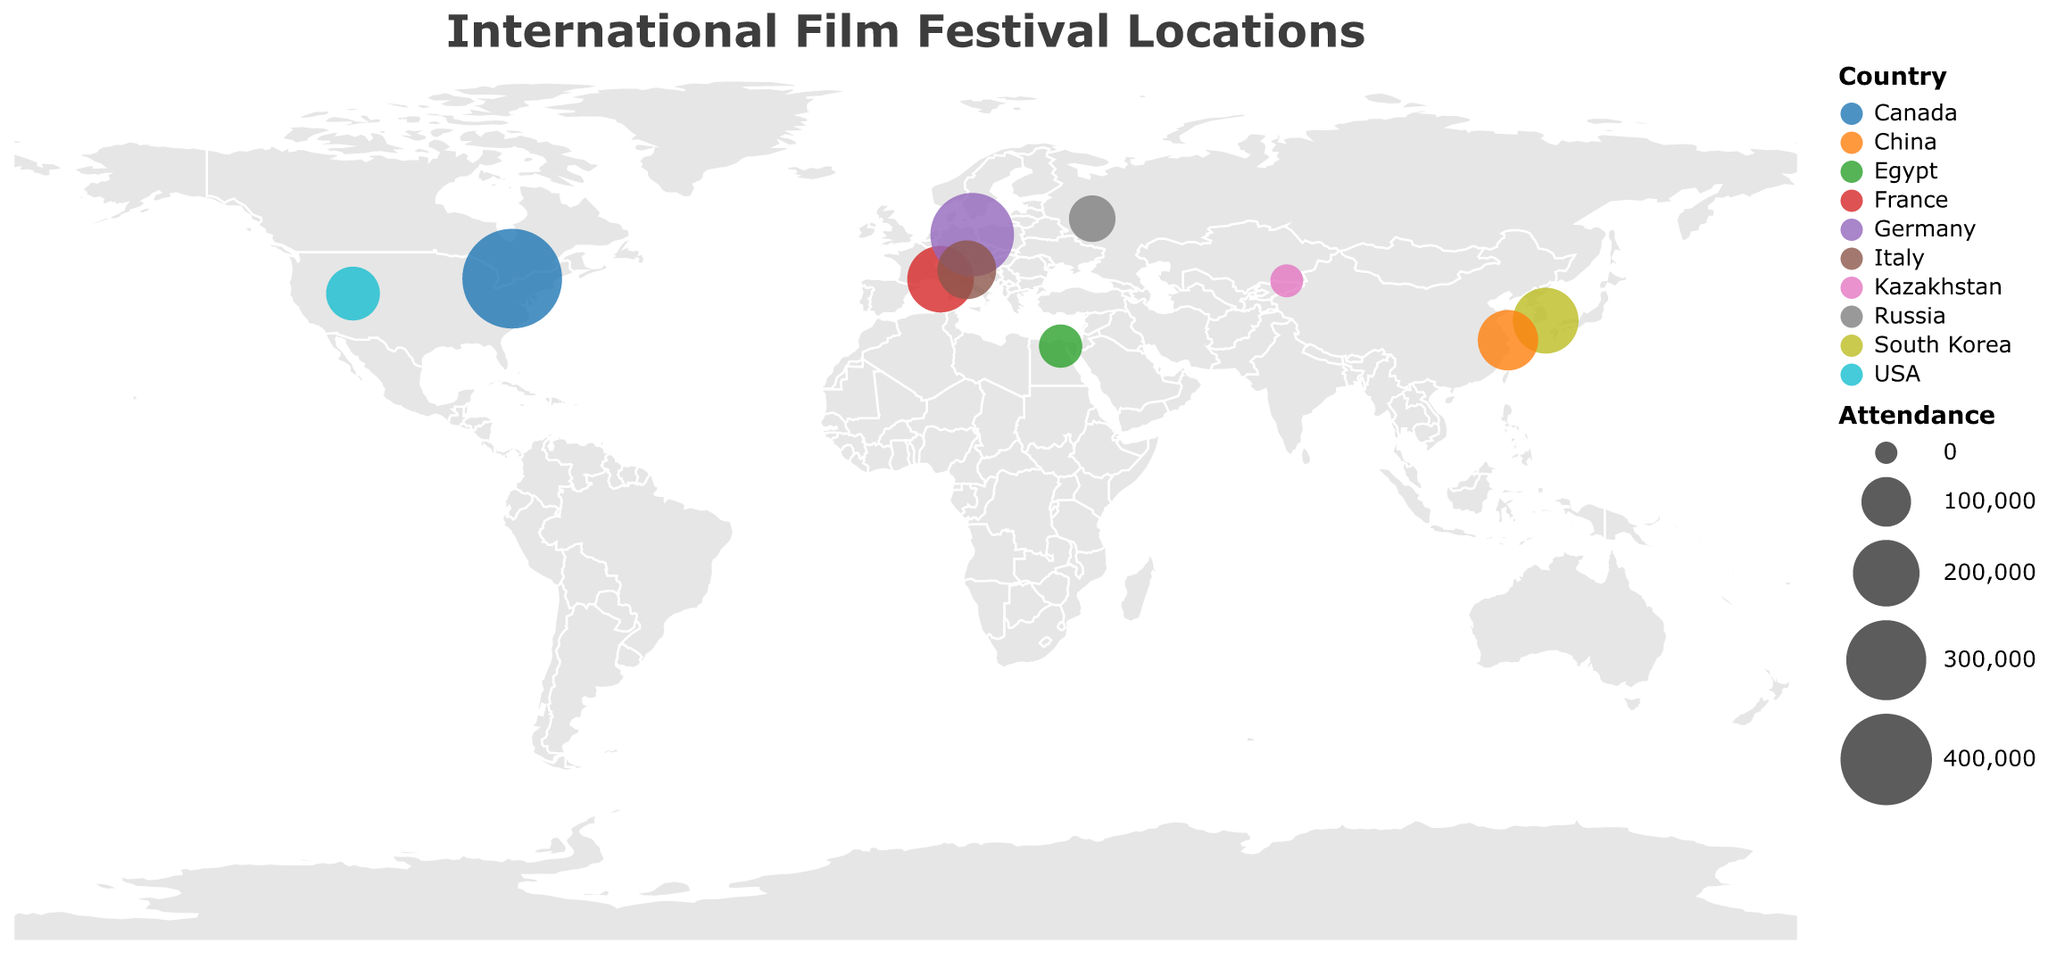What is the title of the figure? The title is displayed at the top of the figure in a larger font size. From the data, it is described as "International Film Festival Locations."
Answer: International Film Festival Locations How many film festivals are shown on the plot? Each circle on the map represents a film festival. By counting the circles or using the data provided, there are 10 film festivals depicted.
Answer: 10 Which film festival has the highest attendance? Look at the size of the circles on the plot. The largest circle corresponds to the Toronto International Film Festival. According to the data, its attendance is 480,000, the highest.
Answer: Toronto International Film Festival What is the attendance of the film festival in Almaty, Kazakhstan? Hover over or look at the circle located at the coordinates for Almaty, Kazakhstan. From the data, the attendance is 30,000.
Answer: 30,000 Which film festival occurs at the highest latitude? The Berlin International Film Festival occurs in Berlin, Germany, which has the highest latitude of 52.5200 among the listed festivals.
Answer: Berlin International Film Festival How does the attendance of the Busan International Film Festival compare to that of the Moscow International Film Festival? Look at the circle sizes and data. Busan International Film Festival has 195,000 attendees, while Moscow International Film Festival has 85,000 attendees. Thus, Busan's attendance is higher.
Answer: Busan International Film Festival has a higher attendance Which countries have more than one film festival depicted? By analyzing the countries listed in the data and their corresponding circles on the map, none of the countries have more than one film festival depicted.
Answer: None What is the total attendance of all film festivals combined? Sum the attendance values for all film festivals: 200,000 + 330,000 + 150,000 + 480,000 + 122,000 + 195,000 + 85,000 + 30,000 + 160,000 + 70,000 = 1,822,000.
Answer: 1,822,000 Which film festival is closest to the Equator? By checking the latitudes, Cairo International Film Festival in Cairo, Egypt, at a latitude of 30.0444, is the closest to the Equator.
Answer: Cairo International Film Festival If you combine the attendance of the Cannes and Venice Film Festivals, what is the total? Add the attendance of the Cannes Film Festival (200,000) and the Venice Film Festival (150,000) to find the combined total: 200,000 + 150,000 = 350,000.
Answer: 350,000 